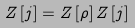<formula> <loc_0><loc_0><loc_500><loc_500>Z \left [ j \right ] = Z \left [ \rho \right ] Z \left [ j \right ]</formula> 